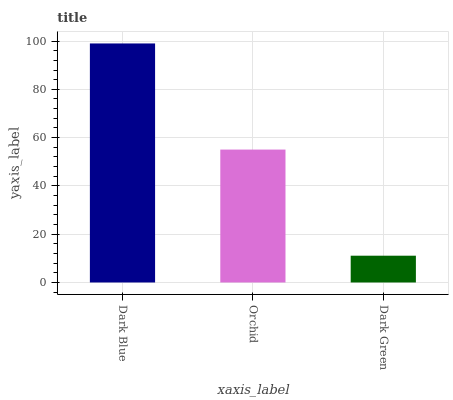Is Dark Green the minimum?
Answer yes or no. Yes. Is Dark Blue the maximum?
Answer yes or no. Yes. Is Orchid the minimum?
Answer yes or no. No. Is Orchid the maximum?
Answer yes or no. No. Is Dark Blue greater than Orchid?
Answer yes or no. Yes. Is Orchid less than Dark Blue?
Answer yes or no. Yes. Is Orchid greater than Dark Blue?
Answer yes or no. No. Is Dark Blue less than Orchid?
Answer yes or no. No. Is Orchid the high median?
Answer yes or no. Yes. Is Orchid the low median?
Answer yes or no. Yes. Is Dark Green the high median?
Answer yes or no. No. Is Dark Green the low median?
Answer yes or no. No. 